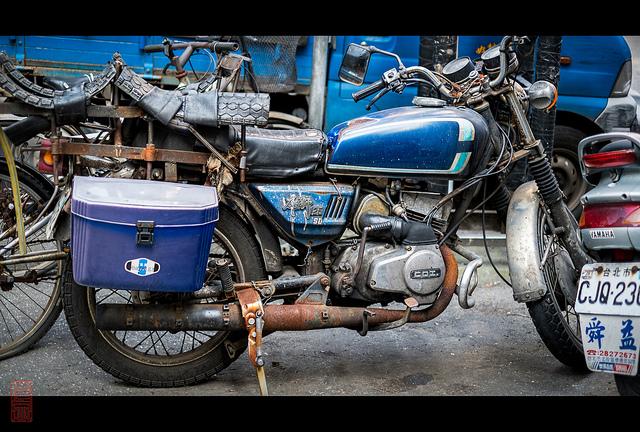How old is this motorcycle?
Keep it brief. Old. What color is the bike?
Be succinct. Blue. How many different shades of blue are on the motorcycle?
Give a very brief answer. 3. 